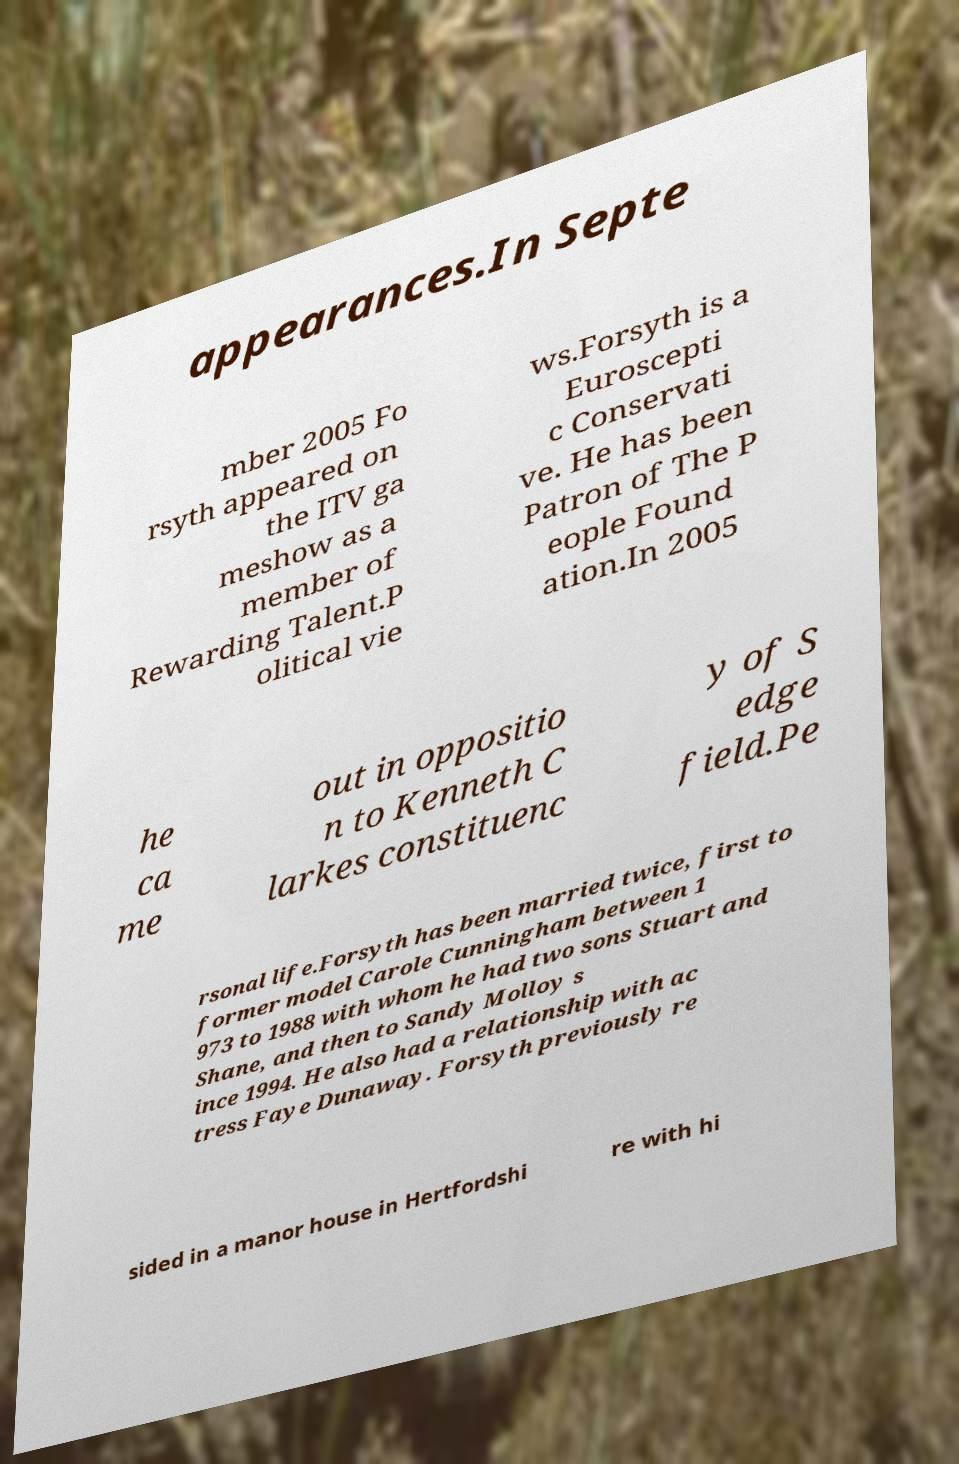I need the written content from this picture converted into text. Can you do that? appearances.In Septe mber 2005 Fo rsyth appeared on the ITV ga meshow as a member of Rewarding Talent.P olitical vie ws.Forsyth is a Euroscepti c Conservati ve. He has been Patron of The P eople Found ation.In 2005 he ca me out in oppositio n to Kenneth C larkes constituenc y of S edge field.Pe rsonal life.Forsyth has been married twice, first to former model Carole Cunningham between 1 973 to 1988 with whom he had two sons Stuart and Shane, and then to Sandy Molloy s ince 1994. He also had a relationship with ac tress Faye Dunaway. Forsyth previously re sided in a manor house in Hertfordshi re with hi 